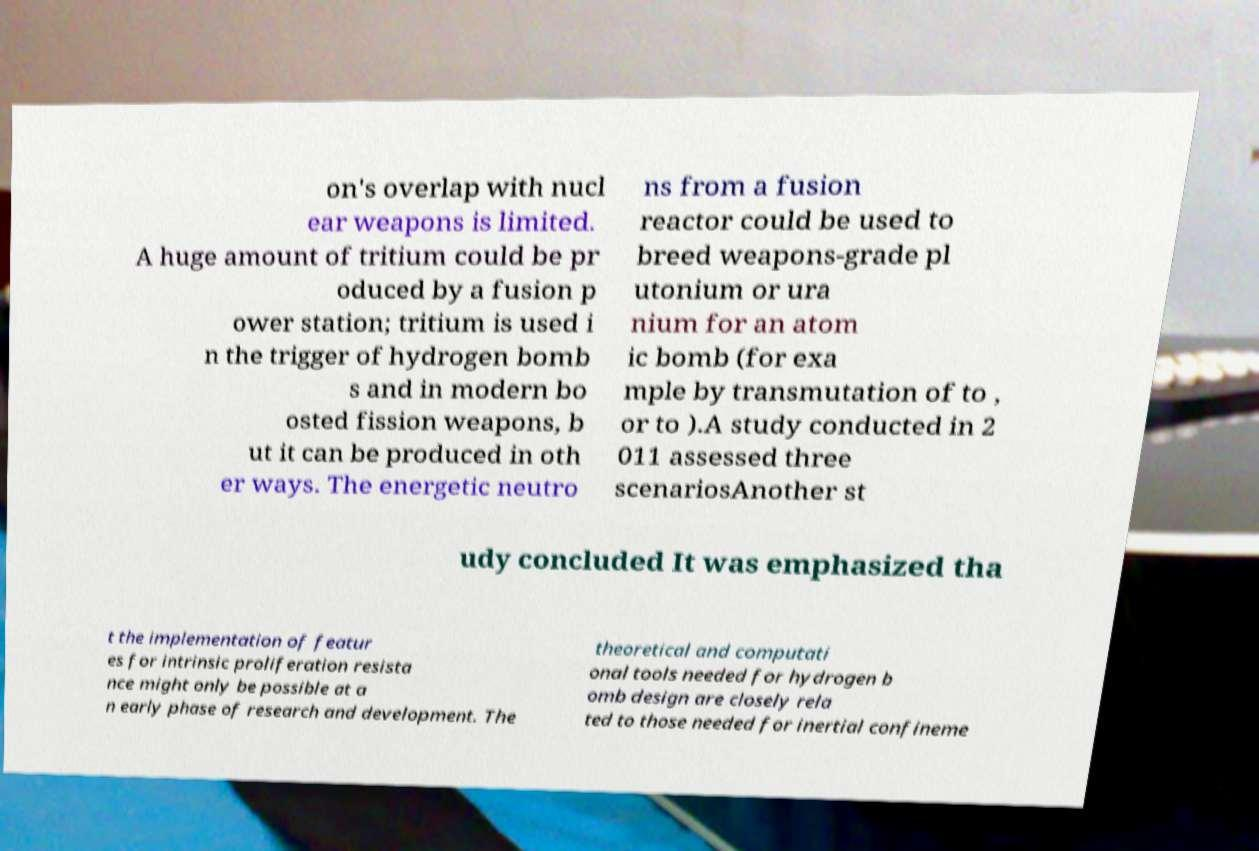Could you assist in decoding the text presented in this image and type it out clearly? on's overlap with nucl ear weapons is limited. A huge amount of tritium could be pr oduced by a fusion p ower station; tritium is used i n the trigger of hydrogen bomb s and in modern bo osted fission weapons, b ut it can be produced in oth er ways. The energetic neutro ns from a fusion reactor could be used to breed weapons-grade pl utonium or ura nium for an atom ic bomb (for exa mple by transmutation of to , or to ).A study conducted in 2 011 assessed three scenariosAnother st udy concluded It was emphasized tha t the implementation of featur es for intrinsic proliferation resista nce might only be possible at a n early phase of research and development. The theoretical and computati onal tools needed for hydrogen b omb design are closely rela ted to those needed for inertial confineme 